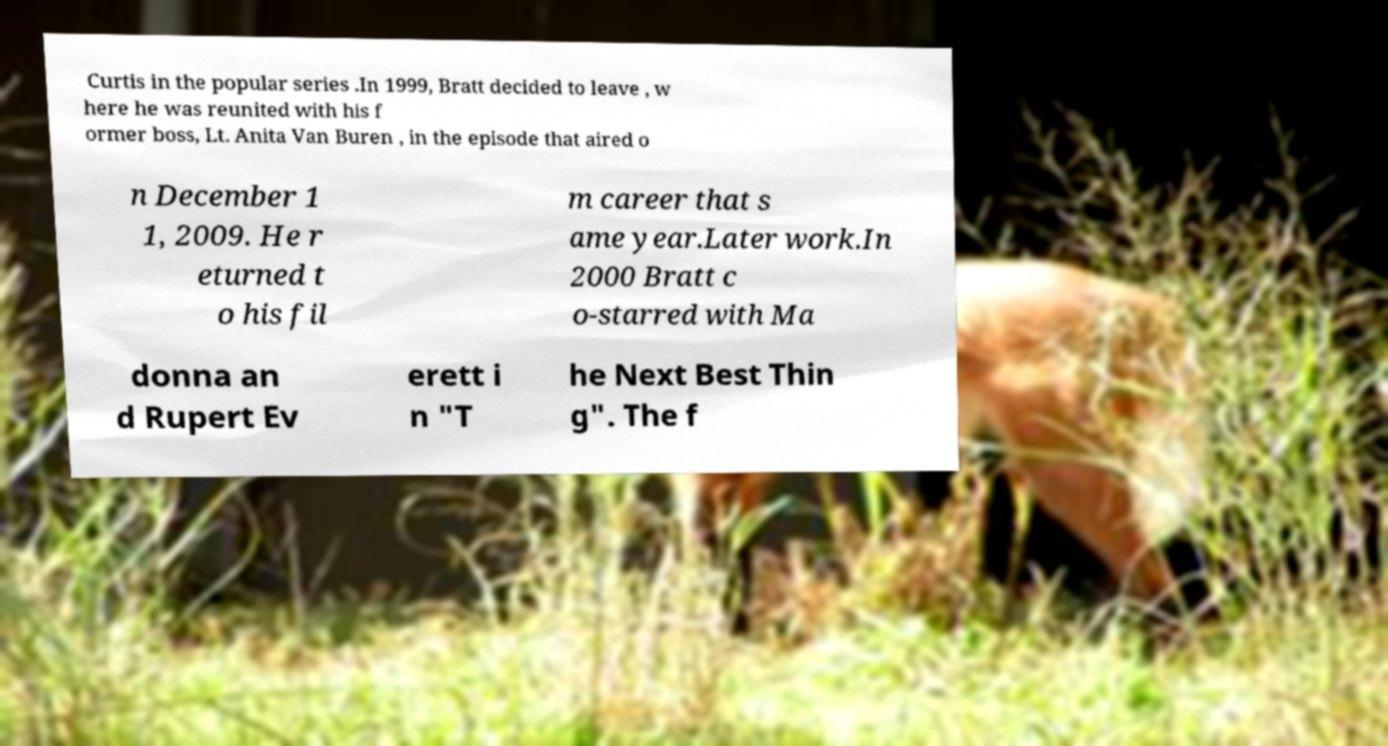For documentation purposes, I need the text within this image transcribed. Could you provide that? Curtis in the popular series .In 1999, Bratt decided to leave , w here he was reunited with his f ormer boss, Lt. Anita Van Buren , in the episode that aired o n December 1 1, 2009. He r eturned t o his fil m career that s ame year.Later work.In 2000 Bratt c o-starred with Ma donna an d Rupert Ev erett i n "T he Next Best Thin g". The f 